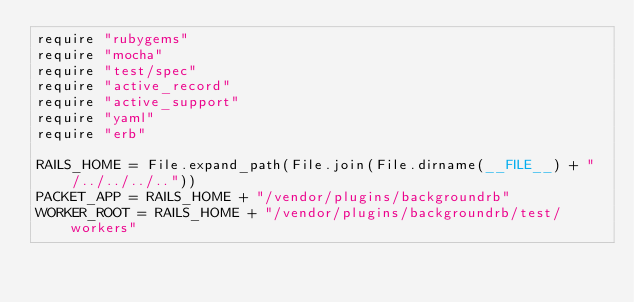<code> <loc_0><loc_0><loc_500><loc_500><_Ruby_>require "rubygems"
require "mocha"
require "test/spec"
require "active_record" 
require "active_support" 
require "yaml"
require "erb"

RAILS_HOME = File.expand_path(File.join(File.dirname(__FILE__) + "/../../../.."))
PACKET_APP = RAILS_HOME + "/vendor/plugins/backgroundrb"
WORKER_ROOT = RAILS_HOME + "/vendor/plugins/backgroundrb/test/workers"</code> 